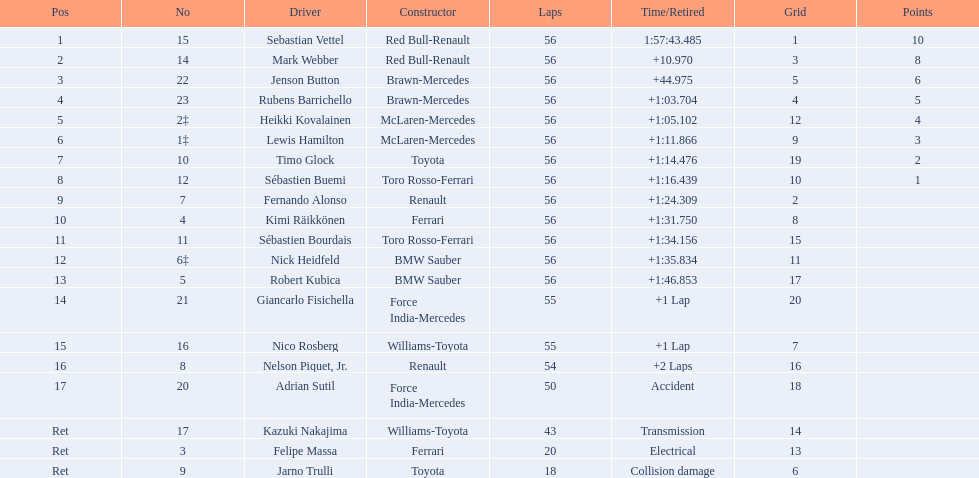How many drivers were unable to finish 56 laps? 7. 